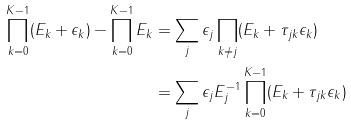<formula> <loc_0><loc_0><loc_500><loc_500>\prod _ { k = 0 } ^ { K - 1 } ( E _ { k } + \epsilon _ { k } ) - \prod _ { k = 0 } ^ { K - 1 } E _ { k } & = \sum _ { j } \epsilon _ { j } \prod _ { k \ne j } ( E _ { k } + \tau _ { j k } \epsilon _ { k } ) \\ & = \sum _ { j } \epsilon _ { j } E ^ { - 1 } _ { j } \prod _ { k = 0 } ^ { K - 1 } ( E _ { k } + \tau _ { j k } \epsilon _ { k } )</formula> 